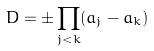Convert formula to latex. <formula><loc_0><loc_0><loc_500><loc_500>D = \pm \prod _ { j < k } ( a _ { j } - a _ { k } )</formula> 